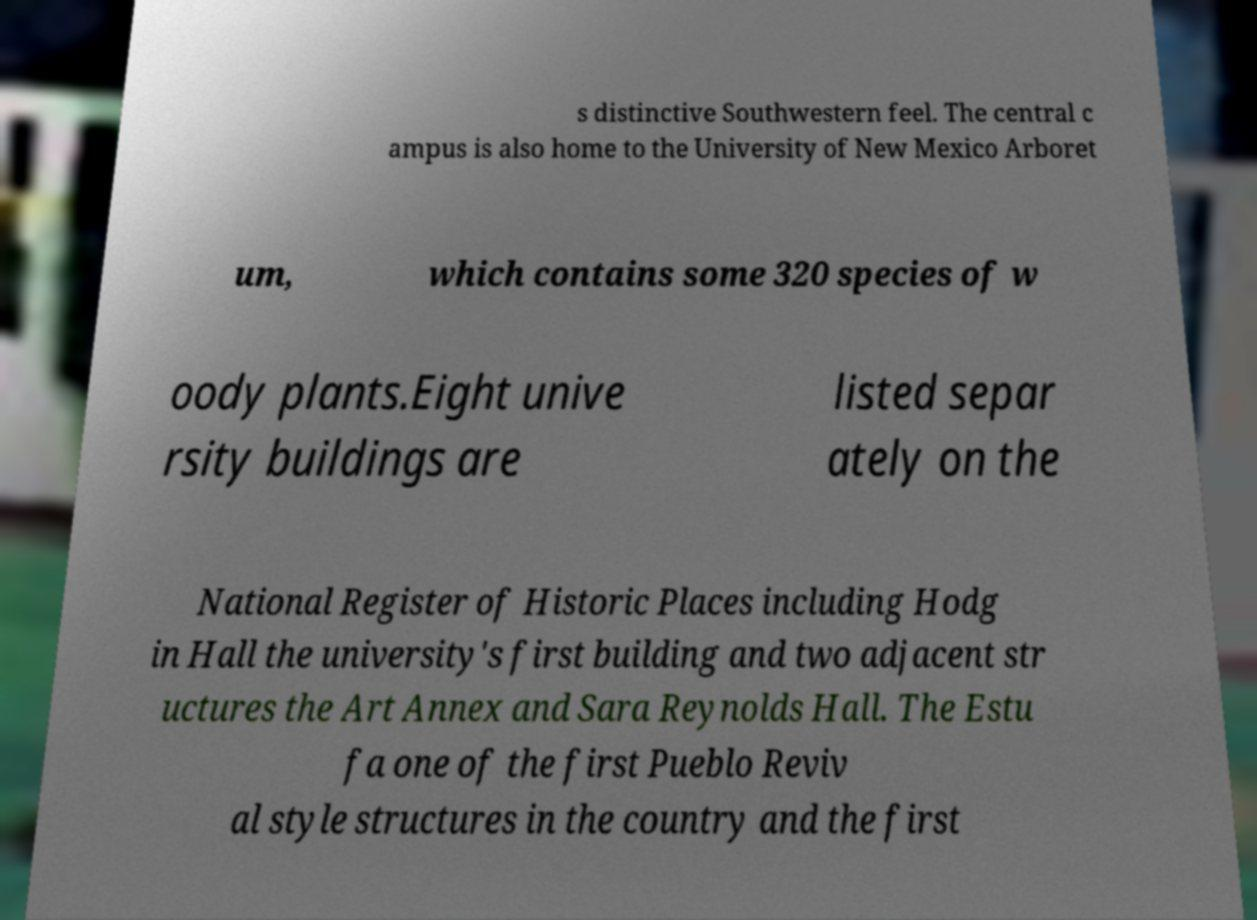Please identify and transcribe the text found in this image. s distinctive Southwestern feel. The central c ampus is also home to the University of New Mexico Arboret um, which contains some 320 species of w oody plants.Eight unive rsity buildings are listed separ ately on the National Register of Historic Places including Hodg in Hall the university's first building and two adjacent str uctures the Art Annex and Sara Reynolds Hall. The Estu fa one of the first Pueblo Reviv al style structures in the country and the first 